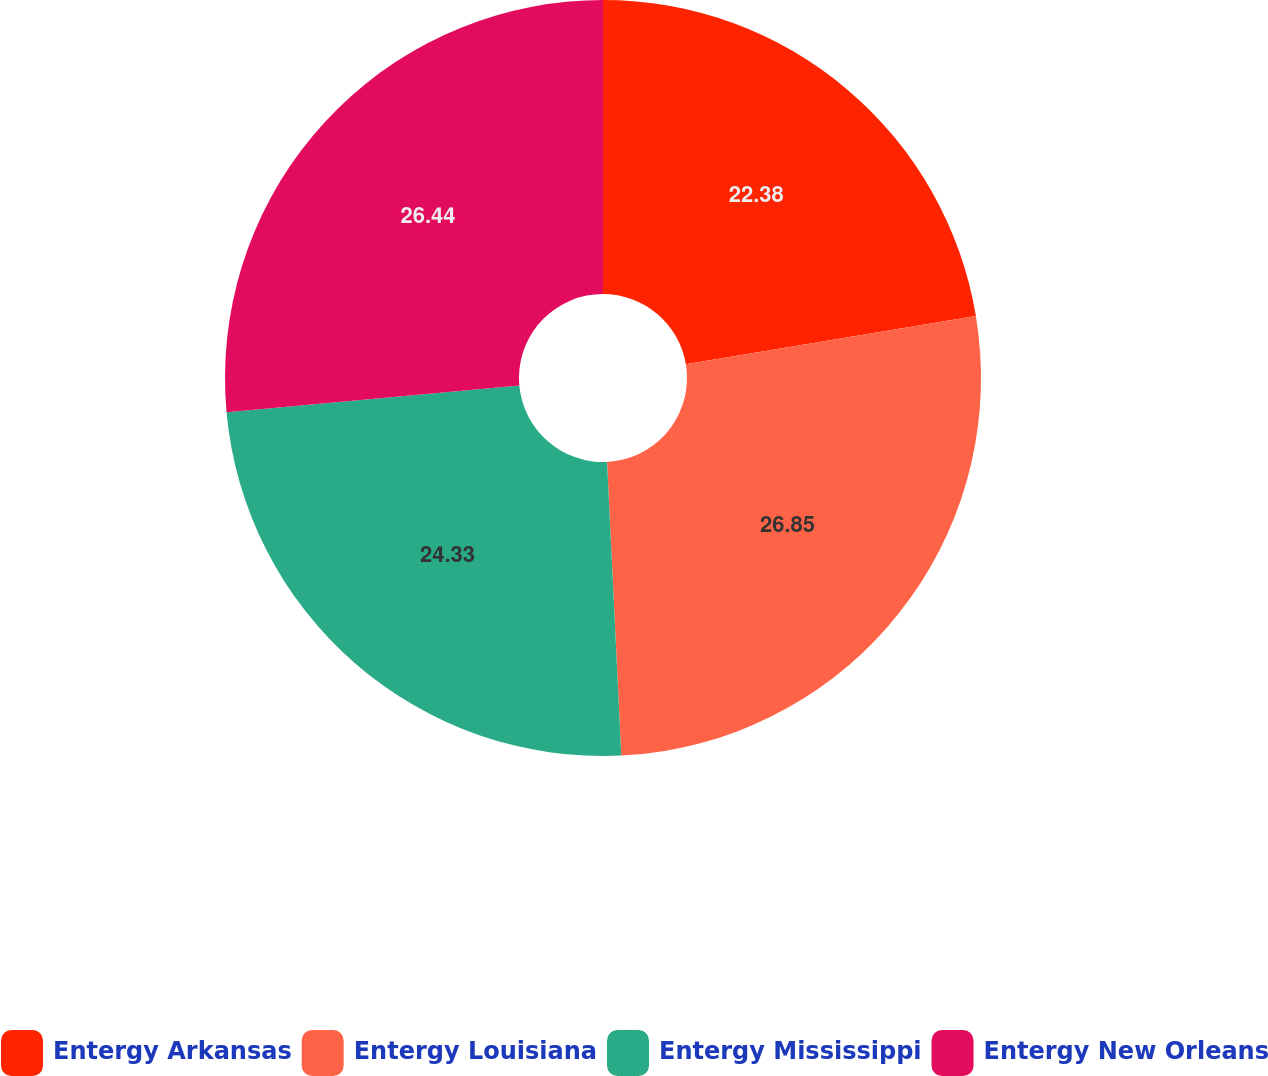Convert chart. <chart><loc_0><loc_0><loc_500><loc_500><pie_chart><fcel>Entergy Arkansas<fcel>Entergy Louisiana<fcel>Entergy Mississippi<fcel>Entergy New Orleans<nl><fcel>22.38%<fcel>26.85%<fcel>24.33%<fcel>26.44%<nl></chart> 